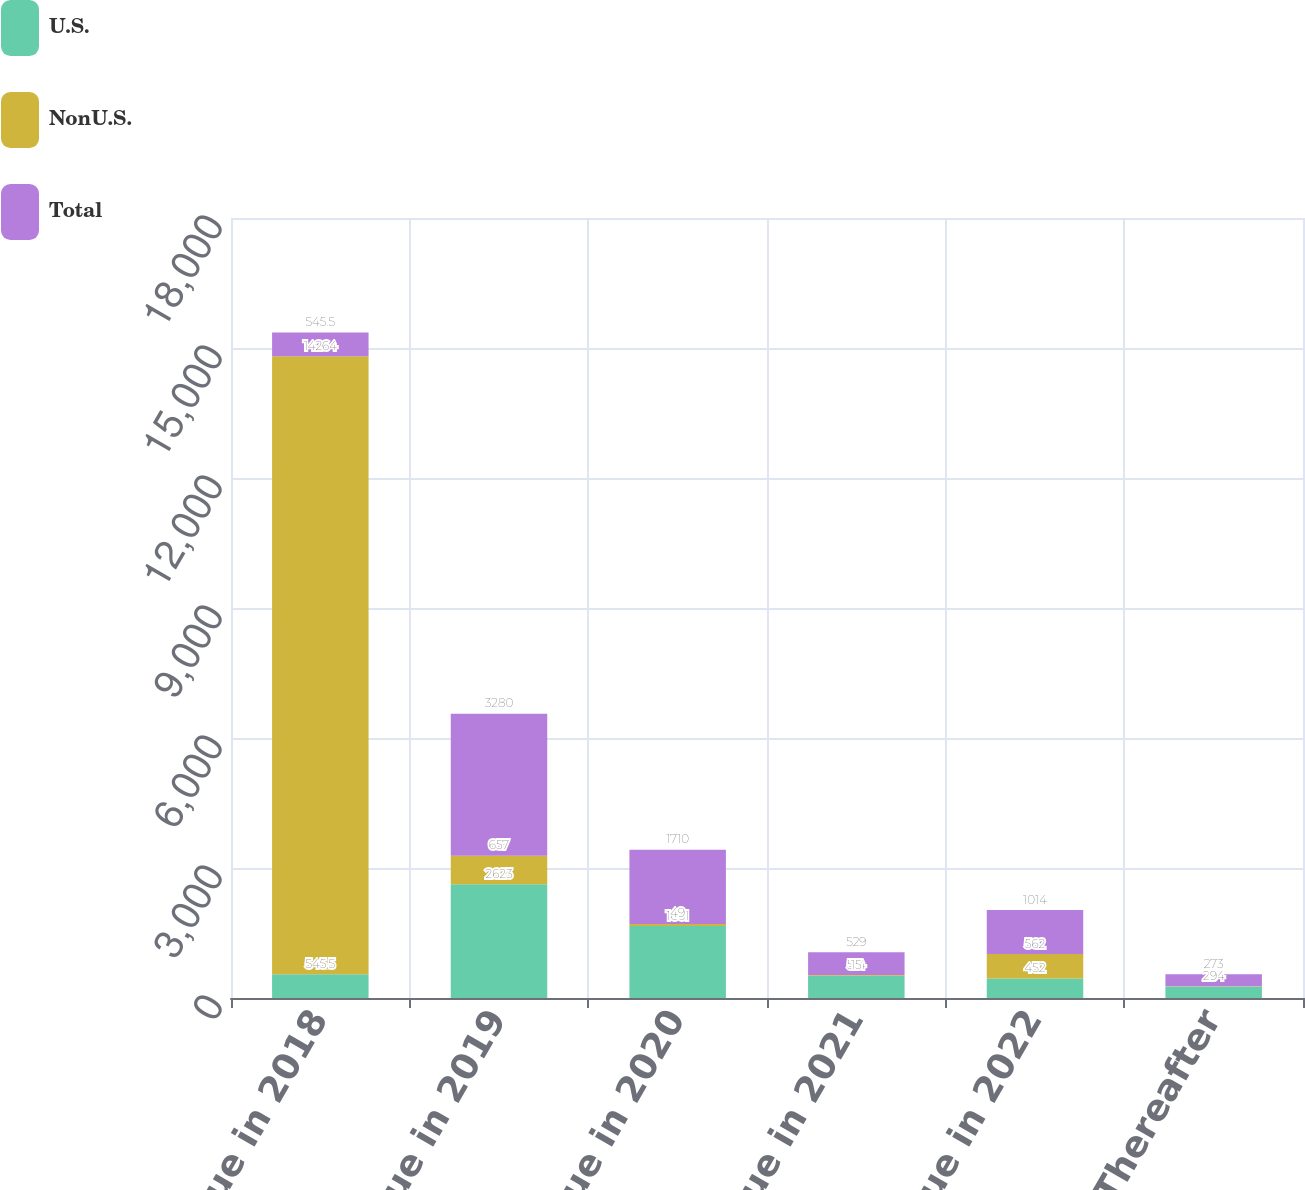<chart> <loc_0><loc_0><loc_500><loc_500><stacked_bar_chart><ecel><fcel>Due in 2018<fcel>Due in 2019<fcel>Due in 2020<fcel>Due in 2021<fcel>Due in 2022<fcel>Thereafter<nl><fcel>U.S.<fcel>545.5<fcel>2623<fcel>1661<fcel>514<fcel>452<fcel>264<nl><fcel>NonU.S.<fcel>14264<fcel>657<fcel>49<fcel>15<fcel>562<fcel>9<nl><fcel>Total<fcel>545.5<fcel>3280<fcel>1710<fcel>529<fcel>1014<fcel>273<nl></chart> 